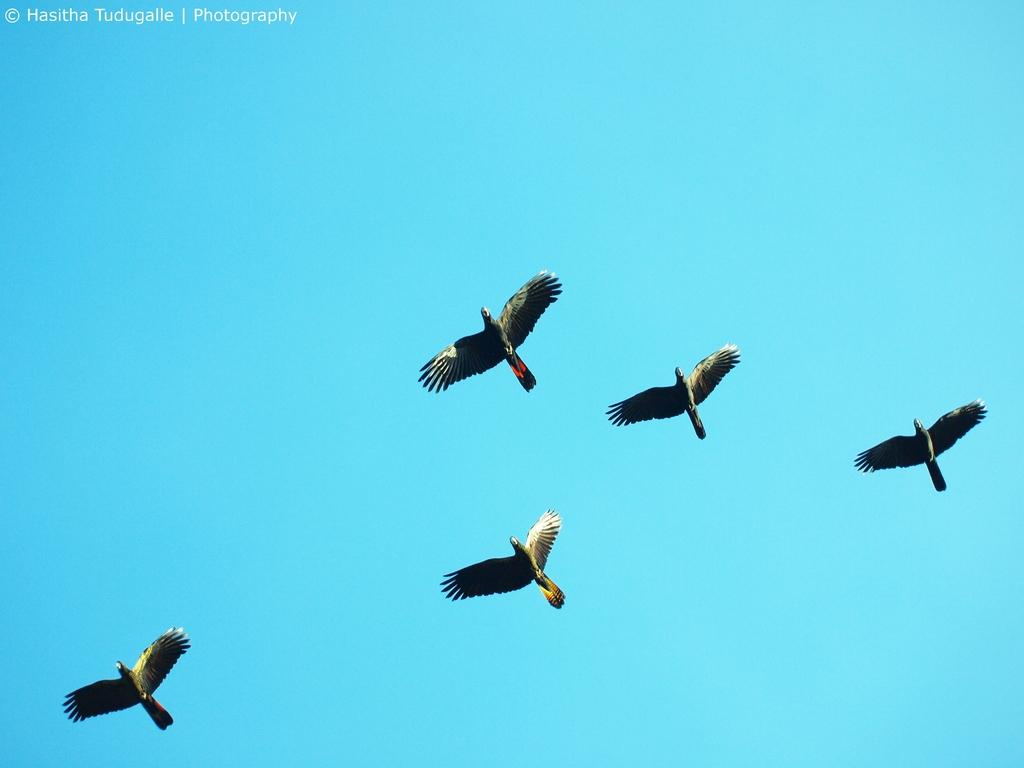How many birds are visible in the image? There are five birds in the image. What are the birds doing in the image? The birds are flying in the sky. What type of destruction is the giraffe causing in the image? There is no giraffe present in the image, and therefore no destruction can be observed. 